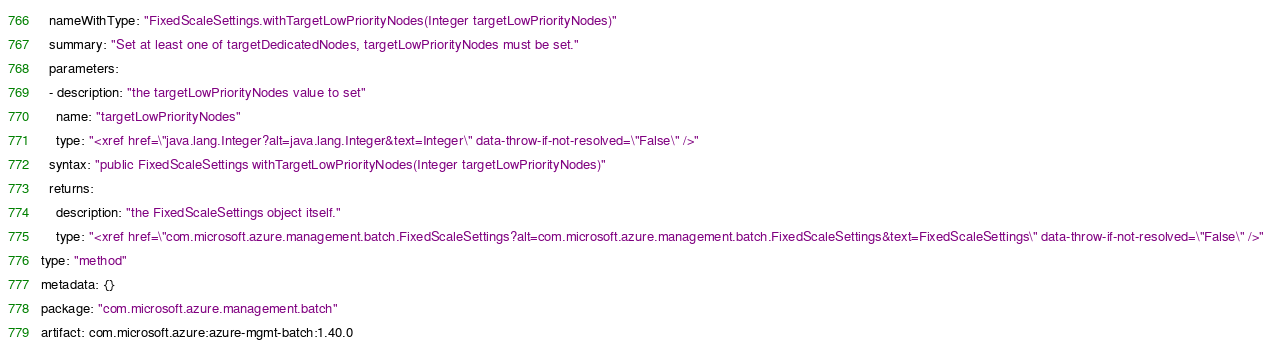Convert code to text. <code><loc_0><loc_0><loc_500><loc_500><_YAML_>  nameWithType: "FixedScaleSettings.withTargetLowPriorityNodes(Integer targetLowPriorityNodes)"
  summary: "Set at least one of targetDedicatedNodes, targetLowPriorityNodes must be set."
  parameters:
  - description: "the targetLowPriorityNodes value to set"
    name: "targetLowPriorityNodes"
    type: "<xref href=\"java.lang.Integer?alt=java.lang.Integer&text=Integer\" data-throw-if-not-resolved=\"False\" />"
  syntax: "public FixedScaleSettings withTargetLowPriorityNodes(Integer targetLowPriorityNodes)"
  returns:
    description: "the FixedScaleSettings object itself."
    type: "<xref href=\"com.microsoft.azure.management.batch.FixedScaleSettings?alt=com.microsoft.azure.management.batch.FixedScaleSettings&text=FixedScaleSettings\" data-throw-if-not-resolved=\"False\" />"
type: "method"
metadata: {}
package: "com.microsoft.azure.management.batch"
artifact: com.microsoft.azure:azure-mgmt-batch:1.40.0
</code> 